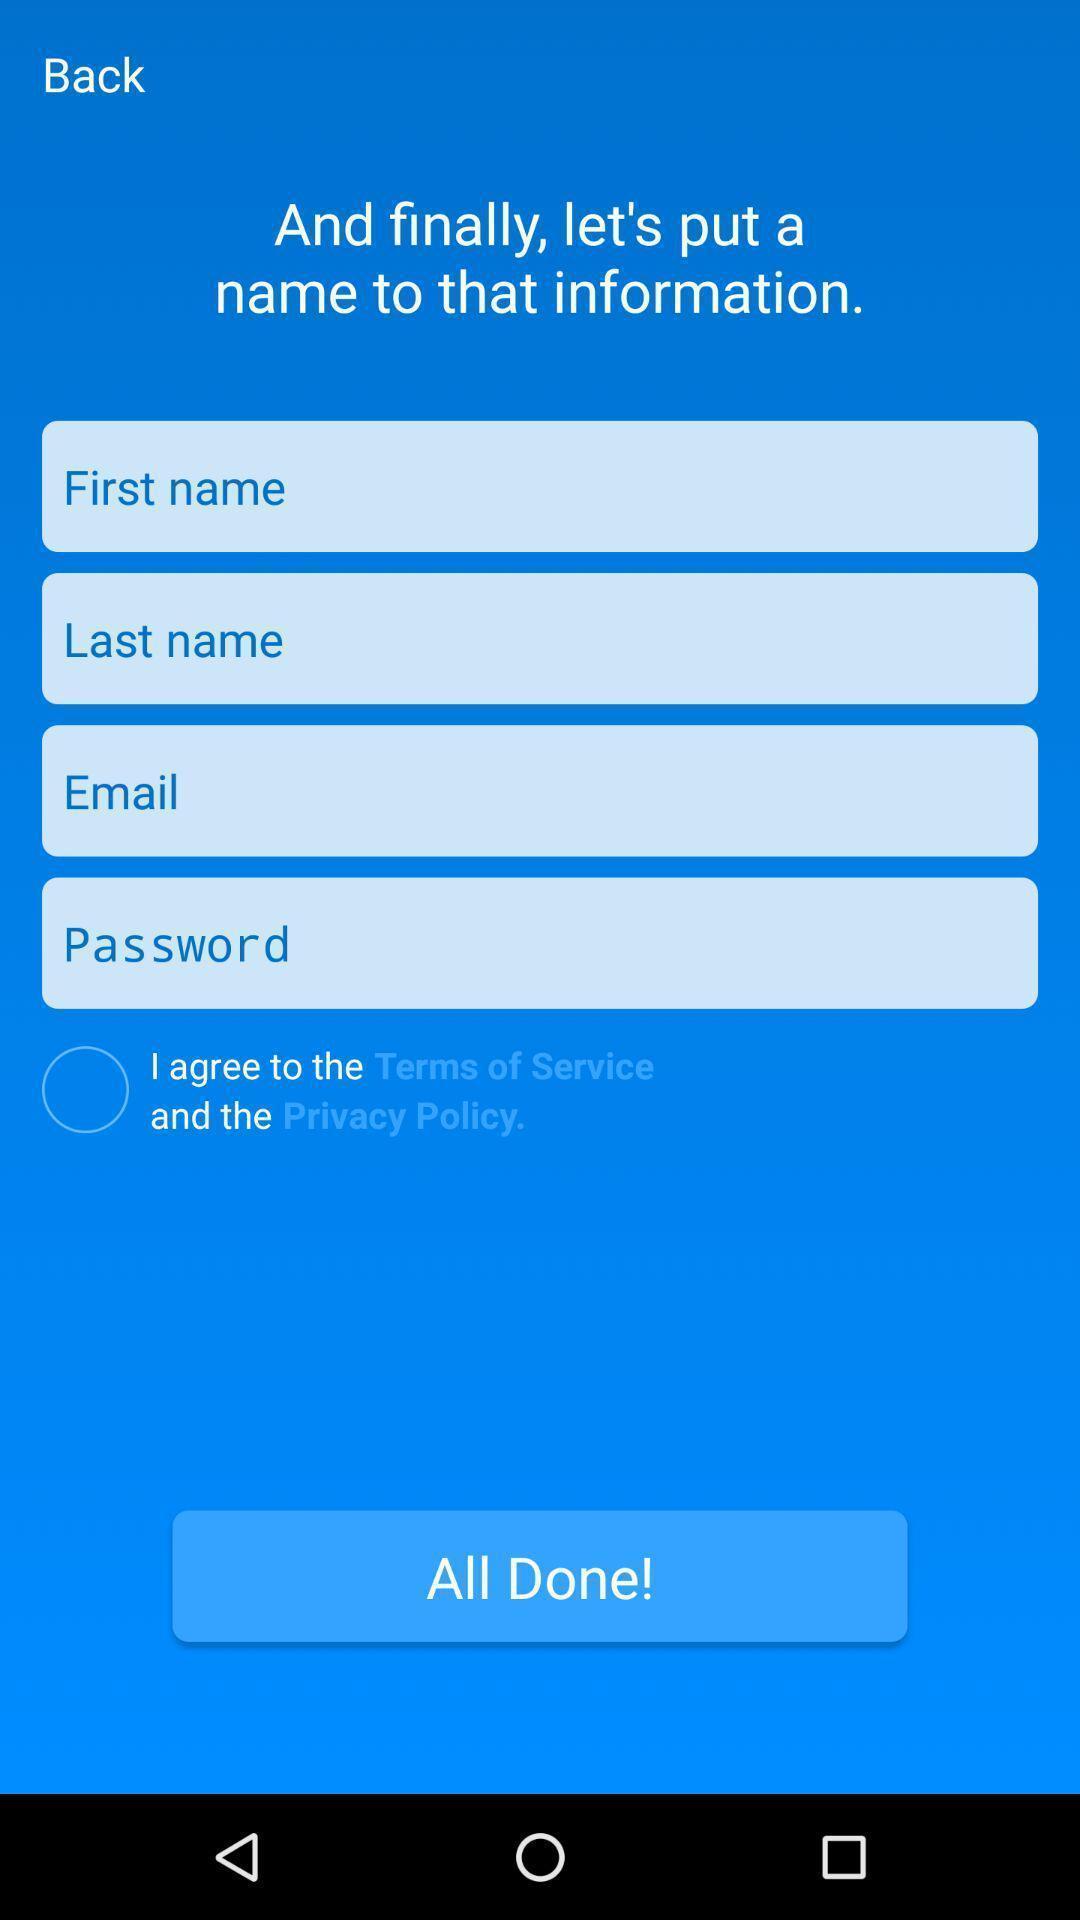Summarize the main components in this picture. Page to enter details to create an account. 